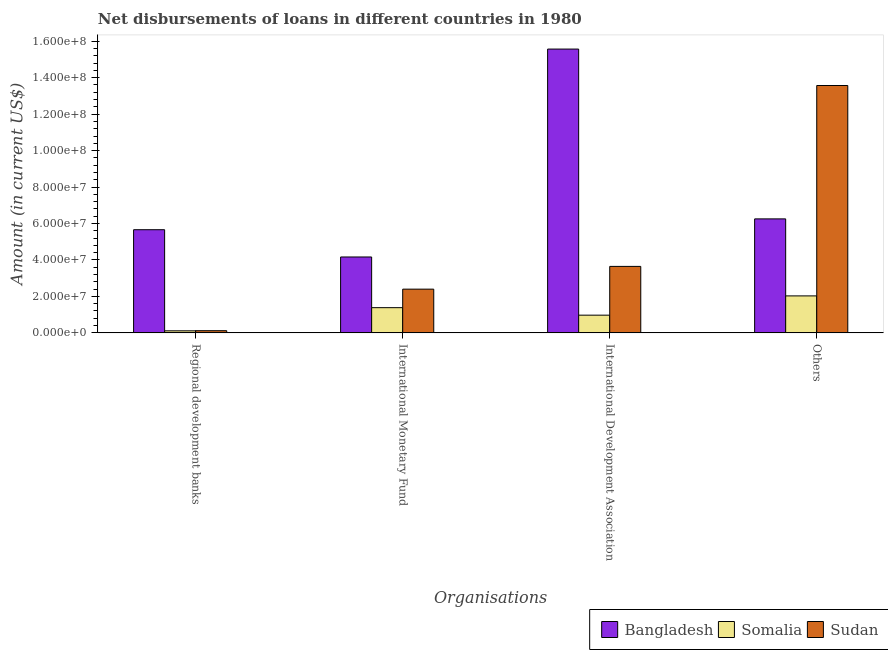How many different coloured bars are there?
Provide a short and direct response. 3. How many groups of bars are there?
Provide a succinct answer. 4. Are the number of bars per tick equal to the number of legend labels?
Your answer should be very brief. Yes. What is the label of the 2nd group of bars from the left?
Ensure brevity in your answer.  International Monetary Fund. What is the amount of loan disimbursed by international monetary fund in Bangladesh?
Provide a succinct answer. 4.16e+07. Across all countries, what is the maximum amount of loan disimbursed by regional development banks?
Provide a short and direct response. 5.66e+07. Across all countries, what is the minimum amount of loan disimbursed by international monetary fund?
Provide a succinct answer. 1.38e+07. In which country was the amount of loan disimbursed by regional development banks maximum?
Your answer should be compact. Bangladesh. In which country was the amount of loan disimbursed by regional development banks minimum?
Keep it short and to the point. Somalia. What is the total amount of loan disimbursed by other organisations in the graph?
Offer a very short reply. 2.19e+08. What is the difference between the amount of loan disimbursed by other organisations in Sudan and that in Somalia?
Keep it short and to the point. 1.15e+08. What is the difference between the amount of loan disimbursed by international development association in Somalia and the amount of loan disimbursed by international monetary fund in Bangladesh?
Keep it short and to the point. -3.19e+07. What is the average amount of loan disimbursed by regional development banks per country?
Keep it short and to the point. 1.96e+07. What is the difference between the amount of loan disimbursed by international development association and amount of loan disimbursed by regional development banks in Sudan?
Offer a terse response. 3.53e+07. In how many countries, is the amount of loan disimbursed by international development association greater than 20000000 US$?
Your answer should be compact. 2. What is the ratio of the amount of loan disimbursed by international monetary fund in Somalia to that in Sudan?
Give a very brief answer. 0.58. Is the difference between the amount of loan disimbursed by international monetary fund in Sudan and Bangladesh greater than the difference between the amount of loan disimbursed by other organisations in Sudan and Bangladesh?
Your answer should be very brief. No. What is the difference between the highest and the second highest amount of loan disimbursed by other organisations?
Your answer should be very brief. 7.32e+07. What is the difference between the highest and the lowest amount of loan disimbursed by other organisations?
Your response must be concise. 1.15e+08. In how many countries, is the amount of loan disimbursed by international development association greater than the average amount of loan disimbursed by international development association taken over all countries?
Your answer should be compact. 1. What does the 2nd bar from the left in Regional development banks represents?
Offer a very short reply. Somalia. What does the 2nd bar from the right in Regional development banks represents?
Offer a terse response. Somalia. Is it the case that in every country, the sum of the amount of loan disimbursed by regional development banks and amount of loan disimbursed by international monetary fund is greater than the amount of loan disimbursed by international development association?
Ensure brevity in your answer.  No. How many bars are there?
Give a very brief answer. 12. How many countries are there in the graph?
Provide a succinct answer. 3. Are the values on the major ticks of Y-axis written in scientific E-notation?
Ensure brevity in your answer.  Yes. Does the graph contain any zero values?
Offer a very short reply. No. Does the graph contain grids?
Offer a terse response. No. What is the title of the graph?
Your response must be concise. Net disbursements of loans in different countries in 1980. Does "Micronesia" appear as one of the legend labels in the graph?
Provide a succinct answer. No. What is the label or title of the X-axis?
Offer a very short reply. Organisations. What is the Amount (in current US$) of Bangladesh in Regional development banks?
Provide a succinct answer. 5.66e+07. What is the Amount (in current US$) of Somalia in Regional development banks?
Ensure brevity in your answer.  1.12e+06. What is the Amount (in current US$) in Sudan in Regional development banks?
Your response must be concise. 1.19e+06. What is the Amount (in current US$) in Bangladesh in International Monetary Fund?
Keep it short and to the point. 4.16e+07. What is the Amount (in current US$) of Somalia in International Monetary Fund?
Offer a terse response. 1.38e+07. What is the Amount (in current US$) of Sudan in International Monetary Fund?
Your answer should be very brief. 2.40e+07. What is the Amount (in current US$) in Bangladesh in International Development Association?
Provide a short and direct response. 1.56e+08. What is the Amount (in current US$) in Somalia in International Development Association?
Provide a succinct answer. 9.72e+06. What is the Amount (in current US$) in Sudan in International Development Association?
Provide a short and direct response. 3.65e+07. What is the Amount (in current US$) of Bangladesh in Others?
Make the answer very short. 6.25e+07. What is the Amount (in current US$) of Somalia in Others?
Give a very brief answer. 2.03e+07. What is the Amount (in current US$) of Sudan in Others?
Offer a terse response. 1.36e+08. Across all Organisations, what is the maximum Amount (in current US$) of Bangladesh?
Provide a succinct answer. 1.56e+08. Across all Organisations, what is the maximum Amount (in current US$) in Somalia?
Offer a terse response. 2.03e+07. Across all Organisations, what is the maximum Amount (in current US$) of Sudan?
Offer a very short reply. 1.36e+08. Across all Organisations, what is the minimum Amount (in current US$) in Bangladesh?
Provide a succinct answer. 4.16e+07. Across all Organisations, what is the minimum Amount (in current US$) in Somalia?
Offer a terse response. 1.12e+06. Across all Organisations, what is the minimum Amount (in current US$) of Sudan?
Your answer should be very brief. 1.19e+06. What is the total Amount (in current US$) in Bangladesh in the graph?
Your answer should be very brief. 3.16e+08. What is the total Amount (in current US$) of Somalia in the graph?
Keep it short and to the point. 4.50e+07. What is the total Amount (in current US$) in Sudan in the graph?
Keep it short and to the point. 1.97e+08. What is the difference between the Amount (in current US$) in Bangladesh in Regional development banks and that in International Monetary Fund?
Give a very brief answer. 1.50e+07. What is the difference between the Amount (in current US$) of Somalia in Regional development banks and that in International Monetary Fund?
Ensure brevity in your answer.  -1.27e+07. What is the difference between the Amount (in current US$) in Sudan in Regional development banks and that in International Monetary Fund?
Make the answer very short. -2.28e+07. What is the difference between the Amount (in current US$) in Bangladesh in Regional development banks and that in International Development Association?
Keep it short and to the point. -9.91e+07. What is the difference between the Amount (in current US$) in Somalia in Regional development banks and that in International Development Association?
Ensure brevity in your answer.  -8.59e+06. What is the difference between the Amount (in current US$) in Sudan in Regional development banks and that in International Development Association?
Offer a very short reply. -3.53e+07. What is the difference between the Amount (in current US$) of Bangladesh in Regional development banks and that in Others?
Offer a terse response. -5.94e+06. What is the difference between the Amount (in current US$) of Somalia in Regional development banks and that in Others?
Your answer should be compact. -1.92e+07. What is the difference between the Amount (in current US$) in Sudan in Regional development banks and that in Others?
Give a very brief answer. -1.35e+08. What is the difference between the Amount (in current US$) of Bangladesh in International Monetary Fund and that in International Development Association?
Your response must be concise. -1.14e+08. What is the difference between the Amount (in current US$) of Somalia in International Monetary Fund and that in International Development Association?
Your answer should be very brief. 4.11e+06. What is the difference between the Amount (in current US$) in Sudan in International Monetary Fund and that in International Development Association?
Keep it short and to the point. -1.25e+07. What is the difference between the Amount (in current US$) in Bangladesh in International Monetary Fund and that in Others?
Your answer should be very brief. -2.09e+07. What is the difference between the Amount (in current US$) of Somalia in International Monetary Fund and that in Others?
Ensure brevity in your answer.  -6.46e+06. What is the difference between the Amount (in current US$) in Sudan in International Monetary Fund and that in Others?
Provide a succinct answer. -1.12e+08. What is the difference between the Amount (in current US$) in Bangladesh in International Development Association and that in Others?
Ensure brevity in your answer.  9.32e+07. What is the difference between the Amount (in current US$) of Somalia in International Development Association and that in Others?
Your response must be concise. -1.06e+07. What is the difference between the Amount (in current US$) in Sudan in International Development Association and that in Others?
Ensure brevity in your answer.  -9.93e+07. What is the difference between the Amount (in current US$) in Bangladesh in Regional development banks and the Amount (in current US$) in Somalia in International Monetary Fund?
Your response must be concise. 4.28e+07. What is the difference between the Amount (in current US$) of Bangladesh in Regional development banks and the Amount (in current US$) of Sudan in International Monetary Fund?
Give a very brief answer. 3.26e+07. What is the difference between the Amount (in current US$) of Somalia in Regional development banks and the Amount (in current US$) of Sudan in International Monetary Fund?
Provide a short and direct response. -2.29e+07. What is the difference between the Amount (in current US$) of Bangladesh in Regional development banks and the Amount (in current US$) of Somalia in International Development Association?
Offer a terse response. 4.69e+07. What is the difference between the Amount (in current US$) of Bangladesh in Regional development banks and the Amount (in current US$) of Sudan in International Development Association?
Your answer should be very brief. 2.01e+07. What is the difference between the Amount (in current US$) of Somalia in Regional development banks and the Amount (in current US$) of Sudan in International Development Association?
Provide a succinct answer. -3.53e+07. What is the difference between the Amount (in current US$) of Bangladesh in Regional development banks and the Amount (in current US$) of Somalia in Others?
Your answer should be compact. 3.63e+07. What is the difference between the Amount (in current US$) of Bangladesh in Regional development banks and the Amount (in current US$) of Sudan in Others?
Your answer should be very brief. -7.91e+07. What is the difference between the Amount (in current US$) in Somalia in Regional development banks and the Amount (in current US$) in Sudan in Others?
Provide a succinct answer. -1.35e+08. What is the difference between the Amount (in current US$) of Bangladesh in International Monetary Fund and the Amount (in current US$) of Somalia in International Development Association?
Give a very brief answer. 3.19e+07. What is the difference between the Amount (in current US$) in Bangladesh in International Monetary Fund and the Amount (in current US$) in Sudan in International Development Association?
Offer a very short reply. 5.17e+06. What is the difference between the Amount (in current US$) in Somalia in International Monetary Fund and the Amount (in current US$) in Sudan in International Development Association?
Your answer should be compact. -2.26e+07. What is the difference between the Amount (in current US$) in Bangladesh in International Monetary Fund and the Amount (in current US$) in Somalia in Others?
Your answer should be compact. 2.14e+07. What is the difference between the Amount (in current US$) in Bangladesh in International Monetary Fund and the Amount (in current US$) in Sudan in Others?
Your response must be concise. -9.41e+07. What is the difference between the Amount (in current US$) of Somalia in International Monetary Fund and the Amount (in current US$) of Sudan in Others?
Provide a short and direct response. -1.22e+08. What is the difference between the Amount (in current US$) in Bangladesh in International Development Association and the Amount (in current US$) in Somalia in Others?
Your answer should be very brief. 1.35e+08. What is the difference between the Amount (in current US$) in Bangladesh in International Development Association and the Amount (in current US$) in Sudan in Others?
Your answer should be compact. 2.00e+07. What is the difference between the Amount (in current US$) of Somalia in International Development Association and the Amount (in current US$) of Sudan in Others?
Offer a very short reply. -1.26e+08. What is the average Amount (in current US$) in Bangladesh per Organisations?
Your response must be concise. 7.91e+07. What is the average Amount (in current US$) in Somalia per Organisations?
Ensure brevity in your answer.  1.12e+07. What is the average Amount (in current US$) in Sudan per Organisations?
Provide a succinct answer. 4.93e+07. What is the difference between the Amount (in current US$) of Bangladesh and Amount (in current US$) of Somalia in Regional development banks?
Give a very brief answer. 5.55e+07. What is the difference between the Amount (in current US$) in Bangladesh and Amount (in current US$) in Sudan in Regional development banks?
Your answer should be very brief. 5.54e+07. What is the difference between the Amount (in current US$) of Somalia and Amount (in current US$) of Sudan in Regional development banks?
Provide a succinct answer. -6.40e+04. What is the difference between the Amount (in current US$) in Bangladesh and Amount (in current US$) in Somalia in International Monetary Fund?
Keep it short and to the point. 2.78e+07. What is the difference between the Amount (in current US$) of Bangladesh and Amount (in current US$) of Sudan in International Monetary Fund?
Offer a terse response. 1.76e+07. What is the difference between the Amount (in current US$) in Somalia and Amount (in current US$) in Sudan in International Monetary Fund?
Your response must be concise. -1.02e+07. What is the difference between the Amount (in current US$) in Bangladesh and Amount (in current US$) in Somalia in International Development Association?
Your response must be concise. 1.46e+08. What is the difference between the Amount (in current US$) of Bangladesh and Amount (in current US$) of Sudan in International Development Association?
Your answer should be very brief. 1.19e+08. What is the difference between the Amount (in current US$) of Somalia and Amount (in current US$) of Sudan in International Development Association?
Your response must be concise. -2.68e+07. What is the difference between the Amount (in current US$) of Bangladesh and Amount (in current US$) of Somalia in Others?
Your answer should be very brief. 4.23e+07. What is the difference between the Amount (in current US$) in Bangladesh and Amount (in current US$) in Sudan in Others?
Provide a short and direct response. -7.32e+07. What is the difference between the Amount (in current US$) of Somalia and Amount (in current US$) of Sudan in Others?
Make the answer very short. -1.15e+08. What is the ratio of the Amount (in current US$) of Bangladesh in Regional development banks to that in International Monetary Fund?
Make the answer very short. 1.36. What is the ratio of the Amount (in current US$) of Somalia in Regional development banks to that in International Monetary Fund?
Your answer should be compact. 0.08. What is the ratio of the Amount (in current US$) of Sudan in Regional development banks to that in International Monetary Fund?
Your answer should be compact. 0.05. What is the ratio of the Amount (in current US$) of Bangladesh in Regional development banks to that in International Development Association?
Make the answer very short. 0.36. What is the ratio of the Amount (in current US$) in Somalia in Regional development banks to that in International Development Association?
Your answer should be compact. 0.12. What is the ratio of the Amount (in current US$) of Sudan in Regional development banks to that in International Development Association?
Your answer should be compact. 0.03. What is the ratio of the Amount (in current US$) of Bangladesh in Regional development banks to that in Others?
Keep it short and to the point. 0.9. What is the ratio of the Amount (in current US$) of Somalia in Regional development banks to that in Others?
Offer a very short reply. 0.06. What is the ratio of the Amount (in current US$) of Sudan in Regional development banks to that in Others?
Provide a short and direct response. 0.01. What is the ratio of the Amount (in current US$) of Bangladesh in International Monetary Fund to that in International Development Association?
Provide a succinct answer. 0.27. What is the ratio of the Amount (in current US$) in Somalia in International Monetary Fund to that in International Development Association?
Provide a succinct answer. 1.42. What is the ratio of the Amount (in current US$) of Sudan in International Monetary Fund to that in International Development Association?
Your answer should be compact. 0.66. What is the ratio of the Amount (in current US$) of Bangladesh in International Monetary Fund to that in Others?
Provide a short and direct response. 0.67. What is the ratio of the Amount (in current US$) in Somalia in International Monetary Fund to that in Others?
Give a very brief answer. 0.68. What is the ratio of the Amount (in current US$) of Sudan in International Monetary Fund to that in Others?
Offer a terse response. 0.18. What is the ratio of the Amount (in current US$) of Bangladesh in International Development Association to that in Others?
Your response must be concise. 2.49. What is the ratio of the Amount (in current US$) in Somalia in International Development Association to that in Others?
Provide a succinct answer. 0.48. What is the ratio of the Amount (in current US$) of Sudan in International Development Association to that in Others?
Provide a short and direct response. 0.27. What is the difference between the highest and the second highest Amount (in current US$) of Bangladesh?
Your answer should be very brief. 9.32e+07. What is the difference between the highest and the second highest Amount (in current US$) in Somalia?
Make the answer very short. 6.46e+06. What is the difference between the highest and the second highest Amount (in current US$) in Sudan?
Provide a succinct answer. 9.93e+07. What is the difference between the highest and the lowest Amount (in current US$) in Bangladesh?
Give a very brief answer. 1.14e+08. What is the difference between the highest and the lowest Amount (in current US$) of Somalia?
Provide a short and direct response. 1.92e+07. What is the difference between the highest and the lowest Amount (in current US$) of Sudan?
Ensure brevity in your answer.  1.35e+08. 